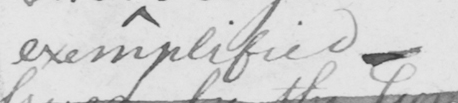Transcribe the text shown in this historical manuscript line. exemplified  _ 